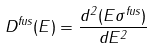Convert formula to latex. <formula><loc_0><loc_0><loc_500><loc_500>D ^ { f u s } ( E ) = \frac { d ^ { 2 } ( E \sigma ^ { f u s } ) } { d E ^ { 2 } }</formula> 